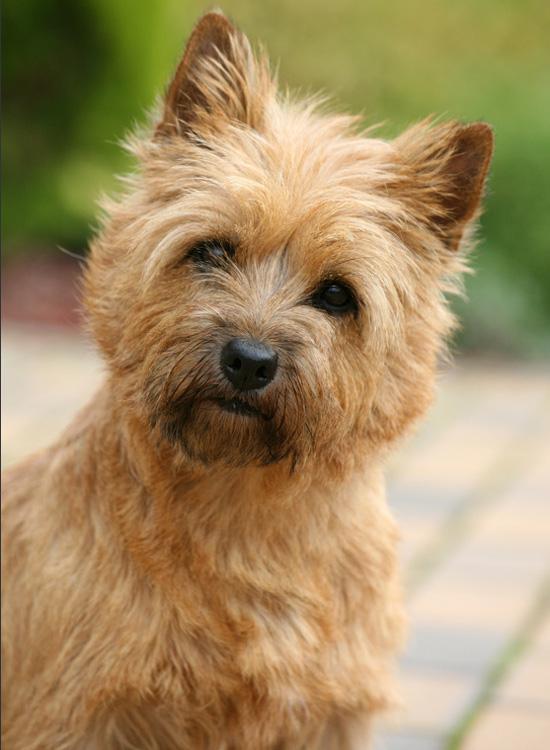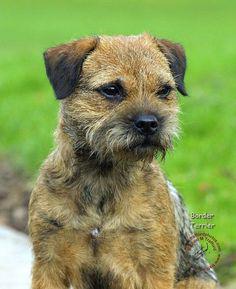The first image is the image on the left, the second image is the image on the right. Examine the images to the left and right. Is the description "the dog in the image on the right is standing on all fours" accurate? Answer yes or no. No. The first image is the image on the left, the second image is the image on the right. Assess this claim about the two images: "There are two dogs sitting on the grass.". Correct or not? Answer yes or no. No. 